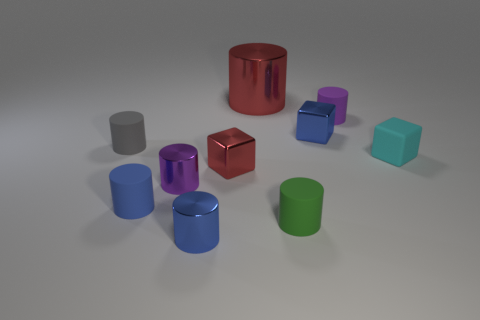The cube that is to the left of the shiny cylinder that is behind the red metallic cube is what color?
Your response must be concise. Red. Is the tiny blue cube made of the same material as the small purple object that is behind the tiny gray rubber cylinder?
Ensure brevity in your answer.  No. There is a red object behind the matte block; what material is it?
Your response must be concise. Metal. Are there the same number of large red metallic cylinders that are in front of the cyan rubber object and tiny brown metallic cylinders?
Keep it short and to the point. Yes. Is there any other thing that is the same size as the red shiny cube?
Keep it short and to the point. Yes. What is the material of the tiny purple thing in front of the red metal object in front of the cyan matte object?
Provide a succinct answer. Metal. There is a tiny object that is to the left of the tiny purple rubber object and behind the small gray rubber cylinder; what is its shape?
Offer a very short reply. Cube. The purple matte object that is the same shape as the tiny gray thing is what size?
Make the answer very short. Small. Is the number of cyan objects that are left of the cyan object less than the number of big yellow matte balls?
Offer a very short reply. No. What size is the gray cylinder left of the tiny cyan rubber block?
Make the answer very short. Small. 